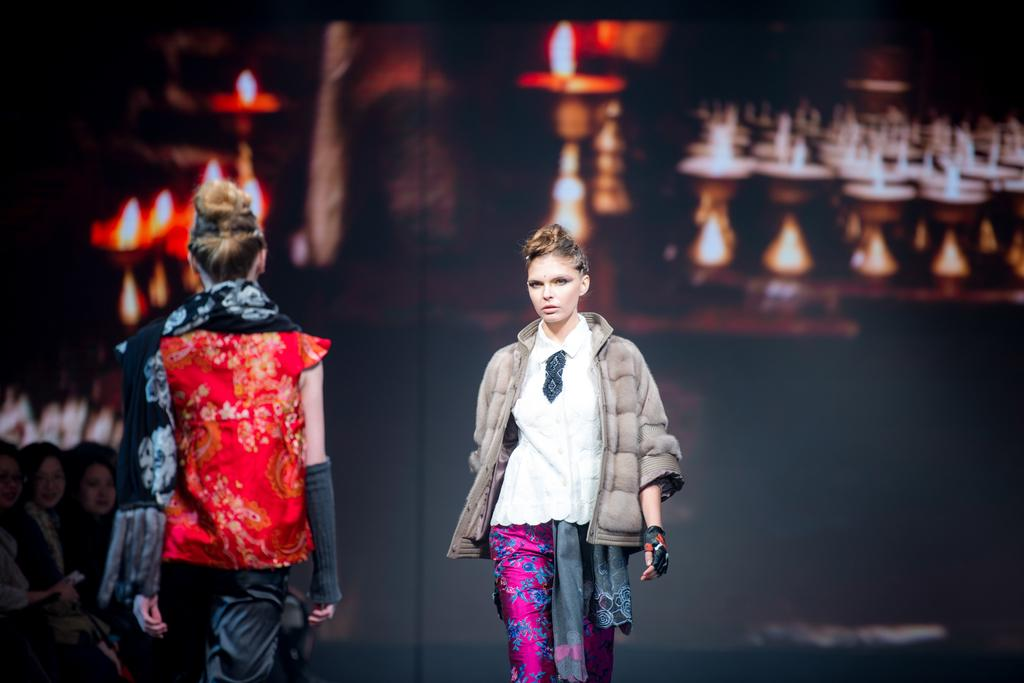What is the main subject of the image? The main subject of the image is a group of people. How can you describe the appearance of the people in the image? The people are wearing different color dresses. What can be seen in the background of the image? There is a screen visible in the background of the image. Reasoning: Let' Let's think step by step in order to produce the conversation. We start by identifying the main subject of the image, which is the group of people. Then, we describe the appearance of the people by mentioning their different color dresses. Finally, we acknowledge the presence of the screen in the background, which adds context to the image. Absurd Question/Answer: What type of effect does the bee have on the group of people in the image? There is no bee present in the image, so it cannot have any effect on the group of people. 